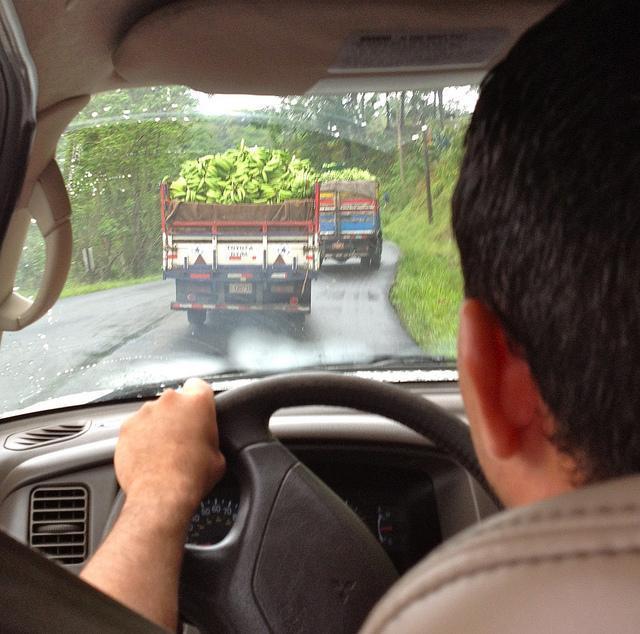How many trucks are in the photo?
Give a very brief answer. 2. How many people are in the photo?
Give a very brief answer. 1. How many umbrellas can be seen?
Give a very brief answer. 0. 